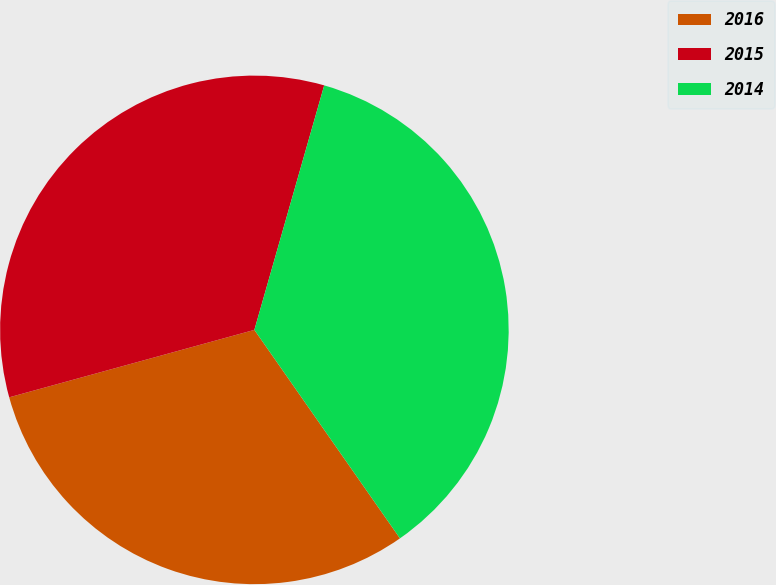<chart> <loc_0><loc_0><loc_500><loc_500><pie_chart><fcel>2016<fcel>2015<fcel>2014<nl><fcel>30.43%<fcel>33.7%<fcel>35.87%<nl></chart> 